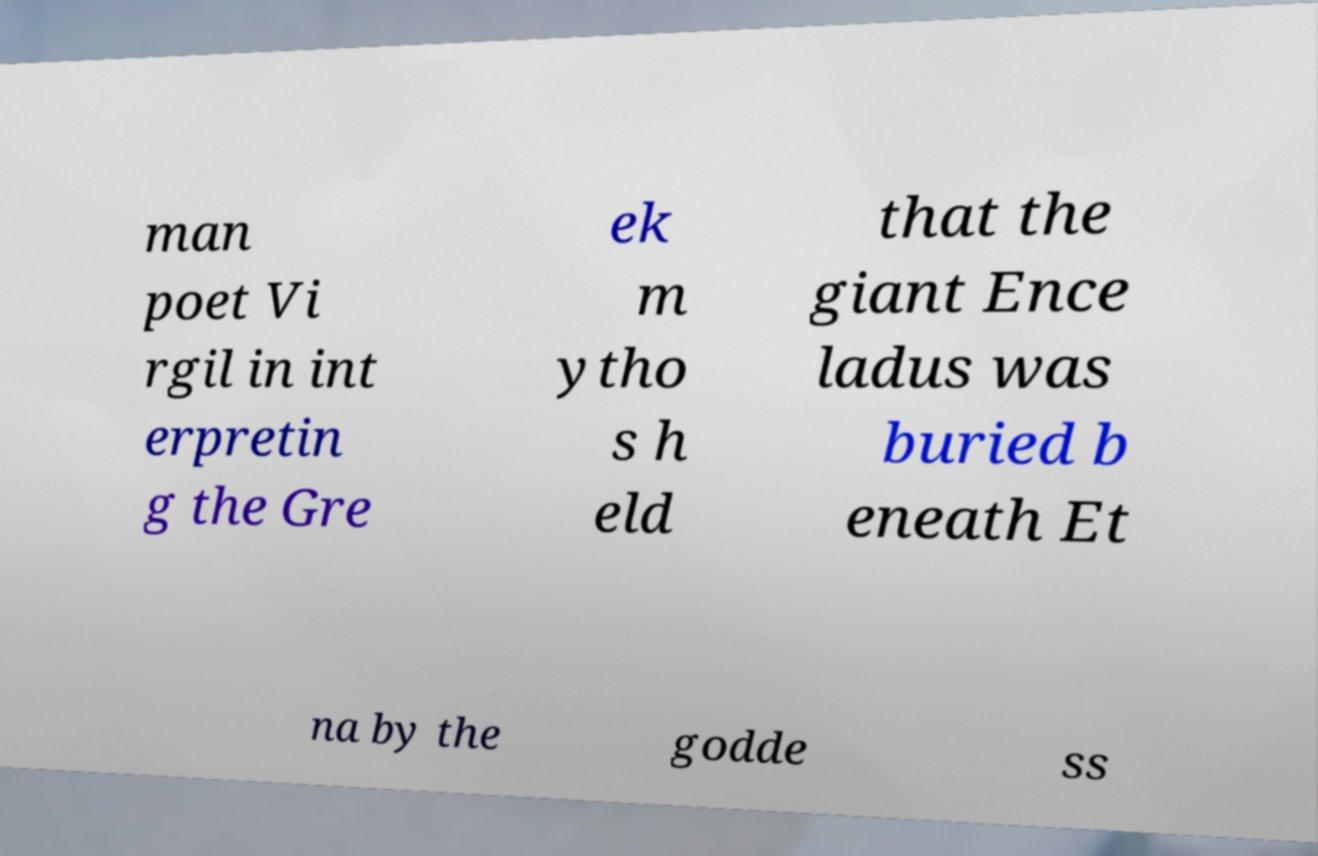For documentation purposes, I need the text within this image transcribed. Could you provide that? man poet Vi rgil in int erpretin g the Gre ek m ytho s h eld that the giant Ence ladus was buried b eneath Et na by the godde ss 